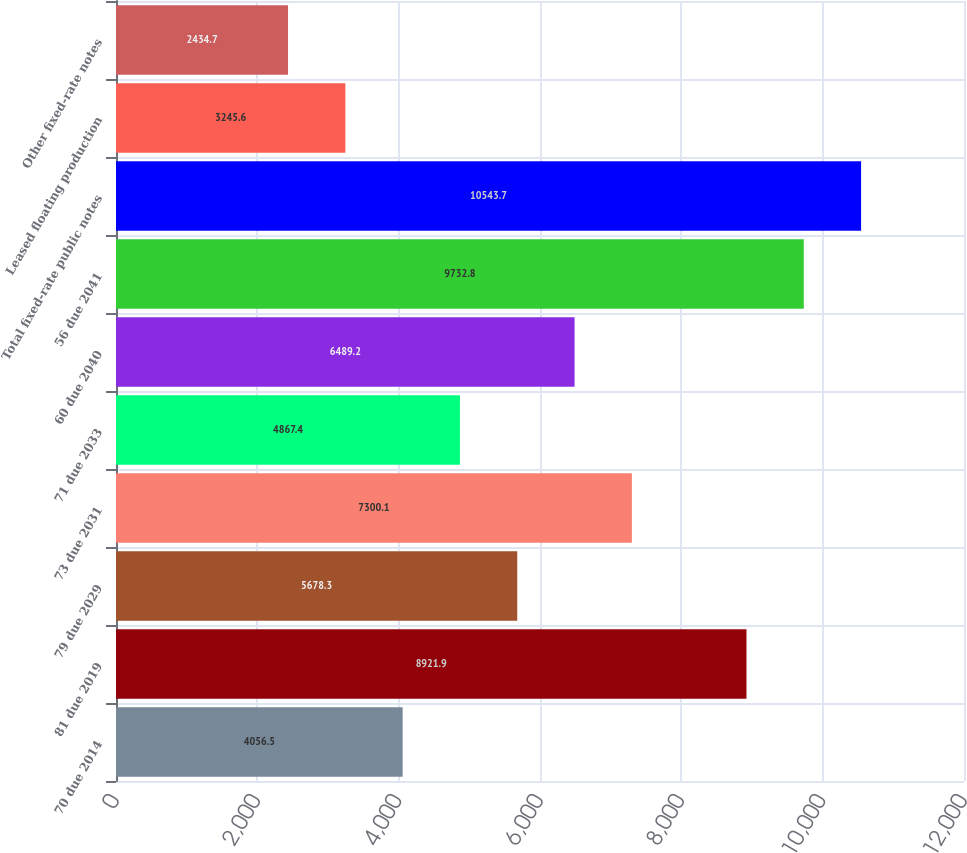Convert chart. <chart><loc_0><loc_0><loc_500><loc_500><bar_chart><fcel>70 due 2014<fcel>81 due 2019<fcel>79 due 2029<fcel>73 due 2031<fcel>71 due 2033<fcel>60 due 2040<fcel>56 due 2041<fcel>Total fixed-rate public notes<fcel>Leased floating production<fcel>Other fixed-rate notes<nl><fcel>4056.5<fcel>8921.9<fcel>5678.3<fcel>7300.1<fcel>4867.4<fcel>6489.2<fcel>9732.8<fcel>10543.7<fcel>3245.6<fcel>2434.7<nl></chart> 